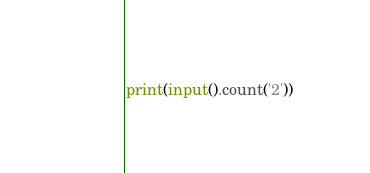<code> <loc_0><loc_0><loc_500><loc_500><_Python_>print(input().count('2'))</code> 